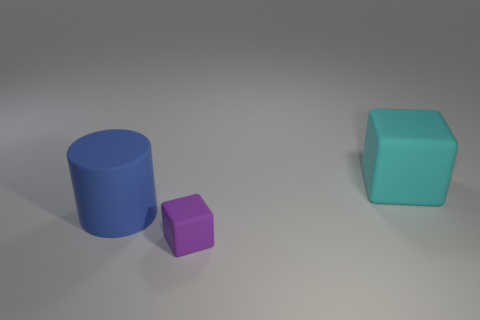Subtract all cubes. How many objects are left? 1 Add 1 large blue matte things. How many large blue matte things are left? 2 Add 1 big rubber blocks. How many big rubber blocks exist? 2 Add 3 cyan blocks. How many objects exist? 6 Subtract all cyan cubes. How many cubes are left? 1 Subtract 0 blue cubes. How many objects are left? 3 Subtract 2 cubes. How many cubes are left? 0 Subtract all brown cylinders. Subtract all blue cubes. How many cylinders are left? 1 Subtract all gray spheres. How many purple cubes are left? 1 Subtract all blue rubber cylinders. Subtract all blue matte cylinders. How many objects are left? 1 